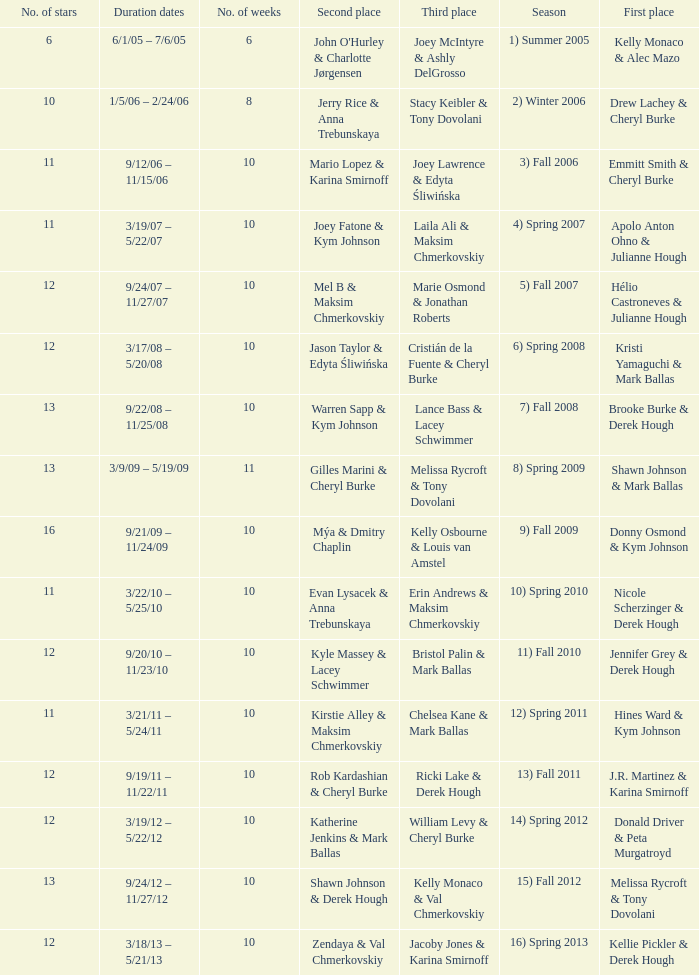Who took first place in week 6? 1.0. 